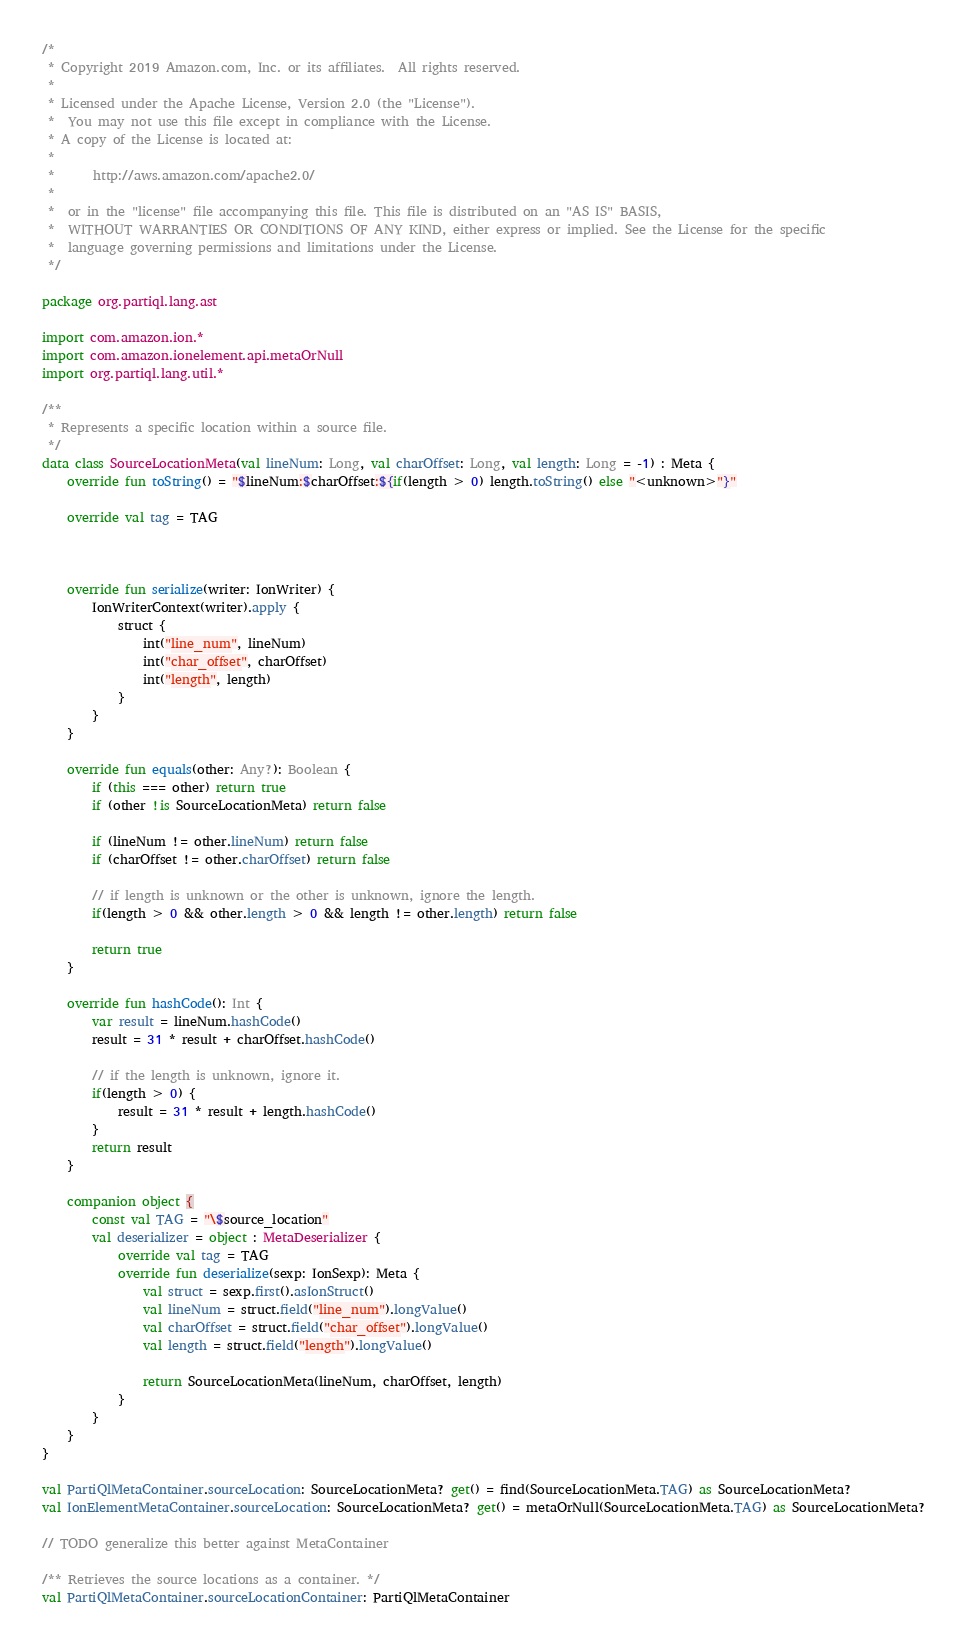<code> <loc_0><loc_0><loc_500><loc_500><_Kotlin_>/*
 * Copyright 2019 Amazon.com, Inc. or its affiliates.  All rights reserved.
 *
 * Licensed under the Apache License, Version 2.0 (the "License").
 *  You may not use this file except in compliance with the License.
 * A copy of the License is located at:
 *
 *      http://aws.amazon.com/apache2.0/
 *
 *  or in the "license" file accompanying this file. This file is distributed on an "AS IS" BASIS,
 *  WITHOUT WARRANTIES OR CONDITIONS OF ANY KIND, either express or implied. See the License for the specific
 *  language governing permissions and limitations under the License.
 */

package org.partiql.lang.ast

import com.amazon.ion.*
import com.amazon.ionelement.api.metaOrNull
import org.partiql.lang.util.*

/**
 * Represents a specific location within a source file.
 */
data class SourceLocationMeta(val lineNum: Long, val charOffset: Long, val length: Long = -1) : Meta {
    override fun toString() = "$lineNum:$charOffset:${if(length > 0) length.toString() else "<unknown>"}"

    override val tag = TAG



    override fun serialize(writer: IonWriter) {
        IonWriterContext(writer).apply {
            struct {
                int("line_num", lineNum)
                int("char_offset", charOffset)
                int("length", length)
            }
        }
    }

    override fun equals(other: Any?): Boolean {
        if (this === other) return true
        if (other !is SourceLocationMeta) return false

        if (lineNum != other.lineNum) return false
        if (charOffset != other.charOffset) return false

        // if length is unknown or the other is unknown, ignore the length.
        if(length > 0 && other.length > 0 && length != other.length) return false

        return true
    }

    override fun hashCode(): Int {
        var result = lineNum.hashCode()
        result = 31 * result + charOffset.hashCode()

        // if the length is unknown, ignore it.
        if(length > 0) {
            result = 31 * result + length.hashCode()
        }
        return result
    }

    companion object {
        const val TAG = "\$source_location"
        val deserializer = object : MetaDeserializer {
            override val tag = TAG
            override fun deserialize(sexp: IonSexp): Meta {
                val struct = sexp.first().asIonStruct()
                val lineNum = struct.field("line_num").longValue()
                val charOffset = struct.field("char_offset").longValue()
                val length = struct.field("length").longValue()

                return SourceLocationMeta(lineNum, charOffset, length)
            }
        }
    }
}

val PartiQlMetaContainer.sourceLocation: SourceLocationMeta? get() = find(SourceLocationMeta.TAG) as SourceLocationMeta?
val IonElementMetaContainer.sourceLocation: SourceLocationMeta? get() = metaOrNull(SourceLocationMeta.TAG) as SourceLocationMeta?

// TODO generalize this better against MetaContainer

/** Retrieves the source locations as a container. */
val PartiQlMetaContainer.sourceLocationContainer: PartiQlMetaContainer</code> 